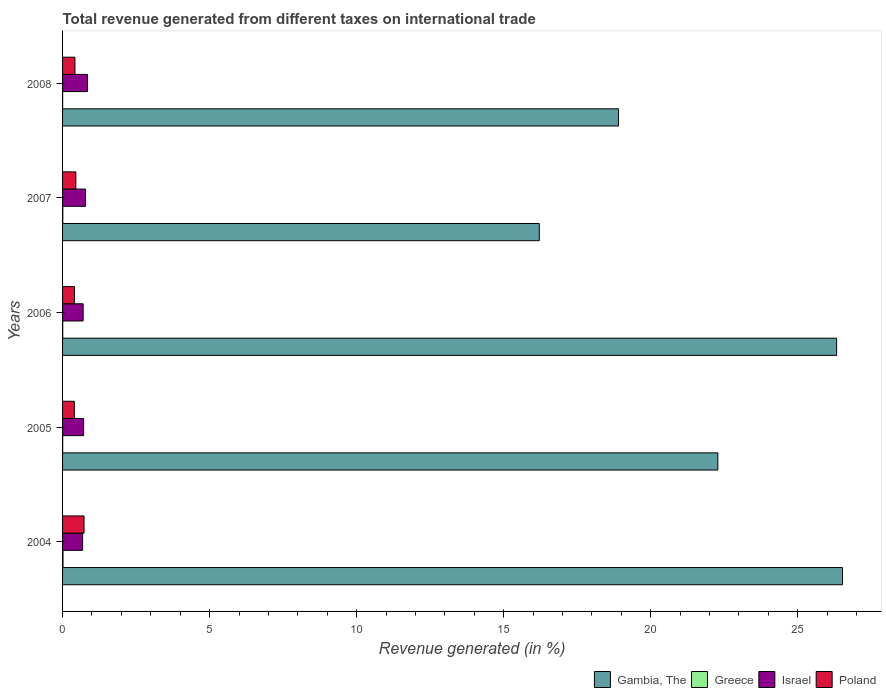How many groups of bars are there?
Your answer should be very brief. 5. How many bars are there on the 2nd tick from the top?
Ensure brevity in your answer.  4. How many bars are there on the 4th tick from the bottom?
Your response must be concise. 4. In how many cases, is the number of bars for a given year not equal to the number of legend labels?
Make the answer very short. 0. What is the total revenue generated in Poland in 2004?
Provide a short and direct response. 0.73. Across all years, what is the maximum total revenue generated in Greece?
Your response must be concise. 0.01. Across all years, what is the minimum total revenue generated in Greece?
Provide a short and direct response. 0. What is the total total revenue generated in Poland in the graph?
Your answer should be compact. 2.41. What is the difference between the total revenue generated in Gambia, The in 2004 and that in 2007?
Your answer should be compact. 10.31. What is the difference between the total revenue generated in Israel in 2004 and the total revenue generated in Poland in 2008?
Offer a very short reply. 0.26. What is the average total revenue generated in Greece per year?
Offer a terse response. 0.01. In the year 2008, what is the difference between the total revenue generated in Israel and total revenue generated in Greece?
Provide a short and direct response. 0.85. In how many years, is the total revenue generated in Israel greater than 15 %?
Keep it short and to the point. 0. What is the ratio of the total revenue generated in Poland in 2004 to that in 2005?
Ensure brevity in your answer.  1.82. Is the total revenue generated in Gambia, The in 2007 less than that in 2008?
Keep it short and to the point. Yes. What is the difference between the highest and the second highest total revenue generated in Poland?
Your response must be concise. 0.28. What is the difference between the highest and the lowest total revenue generated in Poland?
Give a very brief answer. 0.33. Is it the case that in every year, the sum of the total revenue generated in Israel and total revenue generated in Gambia, The is greater than the sum of total revenue generated in Poland and total revenue generated in Greece?
Ensure brevity in your answer.  Yes. What does the 4th bar from the top in 2007 represents?
Your answer should be compact. Gambia, The. Is it the case that in every year, the sum of the total revenue generated in Israel and total revenue generated in Greece is greater than the total revenue generated in Poland?
Your answer should be compact. No. How many bars are there?
Provide a succinct answer. 20. Are all the bars in the graph horizontal?
Keep it short and to the point. Yes. What is the difference between two consecutive major ticks on the X-axis?
Ensure brevity in your answer.  5. Does the graph contain any zero values?
Keep it short and to the point. No. Does the graph contain grids?
Provide a short and direct response. No. How many legend labels are there?
Ensure brevity in your answer.  4. What is the title of the graph?
Ensure brevity in your answer.  Total revenue generated from different taxes on international trade. Does "Venezuela" appear as one of the legend labels in the graph?
Your answer should be compact. No. What is the label or title of the X-axis?
Offer a terse response. Revenue generated (in %). What is the Revenue generated (in %) in Gambia, The in 2004?
Give a very brief answer. 26.52. What is the Revenue generated (in %) of Greece in 2004?
Provide a short and direct response. 0.01. What is the Revenue generated (in %) in Israel in 2004?
Give a very brief answer. 0.68. What is the Revenue generated (in %) of Poland in 2004?
Make the answer very short. 0.73. What is the Revenue generated (in %) in Gambia, The in 2005?
Keep it short and to the point. 22.28. What is the Revenue generated (in %) in Greece in 2005?
Your answer should be very brief. 0. What is the Revenue generated (in %) of Israel in 2005?
Your answer should be compact. 0.72. What is the Revenue generated (in %) in Poland in 2005?
Make the answer very short. 0.4. What is the Revenue generated (in %) of Gambia, The in 2006?
Your answer should be very brief. 26.32. What is the Revenue generated (in %) of Greece in 2006?
Offer a terse response. 0.01. What is the Revenue generated (in %) of Israel in 2006?
Your response must be concise. 0.7. What is the Revenue generated (in %) of Poland in 2006?
Offer a very short reply. 0.4. What is the Revenue generated (in %) of Gambia, The in 2007?
Make the answer very short. 16.21. What is the Revenue generated (in %) in Greece in 2007?
Keep it short and to the point. 0.01. What is the Revenue generated (in %) in Israel in 2007?
Ensure brevity in your answer.  0.78. What is the Revenue generated (in %) of Poland in 2007?
Your answer should be very brief. 0.45. What is the Revenue generated (in %) of Gambia, The in 2008?
Give a very brief answer. 18.9. What is the Revenue generated (in %) in Greece in 2008?
Ensure brevity in your answer.  0. What is the Revenue generated (in %) of Israel in 2008?
Your answer should be compact. 0.85. What is the Revenue generated (in %) in Poland in 2008?
Keep it short and to the point. 0.42. Across all years, what is the maximum Revenue generated (in %) in Gambia, The?
Provide a succinct answer. 26.52. Across all years, what is the maximum Revenue generated (in %) in Greece?
Provide a succinct answer. 0.01. Across all years, what is the maximum Revenue generated (in %) of Israel?
Ensure brevity in your answer.  0.85. Across all years, what is the maximum Revenue generated (in %) of Poland?
Give a very brief answer. 0.73. Across all years, what is the minimum Revenue generated (in %) in Gambia, The?
Offer a terse response. 16.21. Across all years, what is the minimum Revenue generated (in %) in Greece?
Keep it short and to the point. 0. Across all years, what is the minimum Revenue generated (in %) of Israel?
Offer a very short reply. 0.68. Across all years, what is the minimum Revenue generated (in %) of Poland?
Keep it short and to the point. 0.4. What is the total Revenue generated (in %) of Gambia, The in the graph?
Provide a succinct answer. 110.24. What is the total Revenue generated (in %) of Greece in the graph?
Your response must be concise. 0.03. What is the total Revenue generated (in %) in Israel in the graph?
Give a very brief answer. 3.73. What is the total Revenue generated (in %) of Poland in the graph?
Provide a short and direct response. 2.41. What is the difference between the Revenue generated (in %) of Gambia, The in 2004 and that in 2005?
Offer a terse response. 4.24. What is the difference between the Revenue generated (in %) in Greece in 2004 and that in 2005?
Offer a very short reply. 0.01. What is the difference between the Revenue generated (in %) in Israel in 2004 and that in 2005?
Offer a very short reply. -0.03. What is the difference between the Revenue generated (in %) in Poland in 2004 and that in 2005?
Give a very brief answer. 0.33. What is the difference between the Revenue generated (in %) of Gambia, The in 2004 and that in 2006?
Ensure brevity in your answer.  0.2. What is the difference between the Revenue generated (in %) in Greece in 2004 and that in 2006?
Provide a short and direct response. 0.01. What is the difference between the Revenue generated (in %) of Israel in 2004 and that in 2006?
Make the answer very short. -0.02. What is the difference between the Revenue generated (in %) of Poland in 2004 and that in 2006?
Provide a succinct answer. 0.33. What is the difference between the Revenue generated (in %) in Gambia, The in 2004 and that in 2007?
Offer a terse response. 10.31. What is the difference between the Revenue generated (in %) in Greece in 2004 and that in 2007?
Your answer should be very brief. 0.01. What is the difference between the Revenue generated (in %) of Israel in 2004 and that in 2007?
Provide a succinct answer. -0.1. What is the difference between the Revenue generated (in %) in Poland in 2004 and that in 2007?
Make the answer very short. 0.28. What is the difference between the Revenue generated (in %) of Gambia, The in 2004 and that in 2008?
Give a very brief answer. 7.62. What is the difference between the Revenue generated (in %) in Greece in 2004 and that in 2008?
Your answer should be compact. 0.01. What is the difference between the Revenue generated (in %) in Israel in 2004 and that in 2008?
Provide a short and direct response. -0.17. What is the difference between the Revenue generated (in %) in Poland in 2004 and that in 2008?
Your answer should be compact. 0.31. What is the difference between the Revenue generated (in %) in Gambia, The in 2005 and that in 2006?
Keep it short and to the point. -4.04. What is the difference between the Revenue generated (in %) in Greece in 2005 and that in 2006?
Make the answer very short. -0. What is the difference between the Revenue generated (in %) of Israel in 2005 and that in 2006?
Give a very brief answer. 0.02. What is the difference between the Revenue generated (in %) of Poland in 2005 and that in 2006?
Offer a very short reply. -0. What is the difference between the Revenue generated (in %) in Gambia, The in 2005 and that in 2007?
Your response must be concise. 6.07. What is the difference between the Revenue generated (in %) in Greece in 2005 and that in 2007?
Ensure brevity in your answer.  -0. What is the difference between the Revenue generated (in %) of Israel in 2005 and that in 2007?
Make the answer very short. -0.06. What is the difference between the Revenue generated (in %) of Poland in 2005 and that in 2007?
Provide a succinct answer. -0.05. What is the difference between the Revenue generated (in %) in Gambia, The in 2005 and that in 2008?
Offer a terse response. 3.38. What is the difference between the Revenue generated (in %) of Greece in 2005 and that in 2008?
Ensure brevity in your answer.  0. What is the difference between the Revenue generated (in %) of Israel in 2005 and that in 2008?
Your answer should be compact. -0.13. What is the difference between the Revenue generated (in %) in Poland in 2005 and that in 2008?
Give a very brief answer. -0.02. What is the difference between the Revenue generated (in %) in Gambia, The in 2006 and that in 2007?
Make the answer very short. 10.11. What is the difference between the Revenue generated (in %) in Greece in 2006 and that in 2007?
Give a very brief answer. -0. What is the difference between the Revenue generated (in %) of Israel in 2006 and that in 2007?
Provide a succinct answer. -0.08. What is the difference between the Revenue generated (in %) of Poland in 2006 and that in 2007?
Provide a short and direct response. -0.05. What is the difference between the Revenue generated (in %) in Gambia, The in 2006 and that in 2008?
Your answer should be very brief. 7.42. What is the difference between the Revenue generated (in %) in Greece in 2006 and that in 2008?
Provide a short and direct response. 0. What is the difference between the Revenue generated (in %) of Israel in 2006 and that in 2008?
Your answer should be very brief. -0.15. What is the difference between the Revenue generated (in %) of Poland in 2006 and that in 2008?
Your answer should be compact. -0.02. What is the difference between the Revenue generated (in %) in Gambia, The in 2007 and that in 2008?
Your answer should be compact. -2.69. What is the difference between the Revenue generated (in %) of Greece in 2007 and that in 2008?
Keep it short and to the point. 0.01. What is the difference between the Revenue generated (in %) in Israel in 2007 and that in 2008?
Your answer should be very brief. -0.07. What is the difference between the Revenue generated (in %) of Poland in 2007 and that in 2008?
Give a very brief answer. 0.03. What is the difference between the Revenue generated (in %) of Gambia, The in 2004 and the Revenue generated (in %) of Greece in 2005?
Provide a short and direct response. 26.52. What is the difference between the Revenue generated (in %) of Gambia, The in 2004 and the Revenue generated (in %) of Israel in 2005?
Give a very brief answer. 25.81. What is the difference between the Revenue generated (in %) of Gambia, The in 2004 and the Revenue generated (in %) of Poland in 2005?
Your response must be concise. 26.12. What is the difference between the Revenue generated (in %) in Greece in 2004 and the Revenue generated (in %) in Israel in 2005?
Provide a succinct answer. -0.7. What is the difference between the Revenue generated (in %) in Greece in 2004 and the Revenue generated (in %) in Poland in 2005?
Provide a short and direct response. -0.39. What is the difference between the Revenue generated (in %) of Israel in 2004 and the Revenue generated (in %) of Poland in 2005?
Offer a terse response. 0.28. What is the difference between the Revenue generated (in %) of Gambia, The in 2004 and the Revenue generated (in %) of Greece in 2006?
Your answer should be compact. 26.52. What is the difference between the Revenue generated (in %) of Gambia, The in 2004 and the Revenue generated (in %) of Israel in 2006?
Provide a succinct answer. 25.82. What is the difference between the Revenue generated (in %) in Gambia, The in 2004 and the Revenue generated (in %) in Poland in 2006?
Keep it short and to the point. 26.12. What is the difference between the Revenue generated (in %) in Greece in 2004 and the Revenue generated (in %) in Israel in 2006?
Make the answer very short. -0.68. What is the difference between the Revenue generated (in %) of Greece in 2004 and the Revenue generated (in %) of Poland in 2006?
Your response must be concise. -0.39. What is the difference between the Revenue generated (in %) of Israel in 2004 and the Revenue generated (in %) of Poland in 2006?
Provide a succinct answer. 0.28. What is the difference between the Revenue generated (in %) in Gambia, The in 2004 and the Revenue generated (in %) in Greece in 2007?
Your response must be concise. 26.51. What is the difference between the Revenue generated (in %) of Gambia, The in 2004 and the Revenue generated (in %) of Israel in 2007?
Your answer should be compact. 25.74. What is the difference between the Revenue generated (in %) in Gambia, The in 2004 and the Revenue generated (in %) in Poland in 2007?
Make the answer very short. 26.07. What is the difference between the Revenue generated (in %) in Greece in 2004 and the Revenue generated (in %) in Israel in 2007?
Ensure brevity in your answer.  -0.77. What is the difference between the Revenue generated (in %) in Greece in 2004 and the Revenue generated (in %) in Poland in 2007?
Ensure brevity in your answer.  -0.44. What is the difference between the Revenue generated (in %) in Israel in 2004 and the Revenue generated (in %) in Poland in 2007?
Provide a succinct answer. 0.23. What is the difference between the Revenue generated (in %) in Gambia, The in 2004 and the Revenue generated (in %) in Greece in 2008?
Give a very brief answer. 26.52. What is the difference between the Revenue generated (in %) of Gambia, The in 2004 and the Revenue generated (in %) of Israel in 2008?
Provide a succinct answer. 25.67. What is the difference between the Revenue generated (in %) in Gambia, The in 2004 and the Revenue generated (in %) in Poland in 2008?
Provide a succinct answer. 26.1. What is the difference between the Revenue generated (in %) of Greece in 2004 and the Revenue generated (in %) of Israel in 2008?
Give a very brief answer. -0.83. What is the difference between the Revenue generated (in %) in Greece in 2004 and the Revenue generated (in %) in Poland in 2008?
Your answer should be very brief. -0.41. What is the difference between the Revenue generated (in %) of Israel in 2004 and the Revenue generated (in %) of Poland in 2008?
Your response must be concise. 0.26. What is the difference between the Revenue generated (in %) of Gambia, The in 2005 and the Revenue generated (in %) of Greece in 2006?
Offer a very short reply. 22.28. What is the difference between the Revenue generated (in %) of Gambia, The in 2005 and the Revenue generated (in %) of Israel in 2006?
Provide a short and direct response. 21.58. What is the difference between the Revenue generated (in %) of Gambia, The in 2005 and the Revenue generated (in %) of Poland in 2006?
Your response must be concise. 21.88. What is the difference between the Revenue generated (in %) of Greece in 2005 and the Revenue generated (in %) of Israel in 2006?
Give a very brief answer. -0.7. What is the difference between the Revenue generated (in %) in Greece in 2005 and the Revenue generated (in %) in Poland in 2006?
Your answer should be very brief. -0.4. What is the difference between the Revenue generated (in %) of Israel in 2005 and the Revenue generated (in %) of Poland in 2006?
Give a very brief answer. 0.31. What is the difference between the Revenue generated (in %) of Gambia, The in 2005 and the Revenue generated (in %) of Greece in 2007?
Your response must be concise. 22.27. What is the difference between the Revenue generated (in %) in Gambia, The in 2005 and the Revenue generated (in %) in Israel in 2007?
Provide a succinct answer. 21.5. What is the difference between the Revenue generated (in %) in Gambia, The in 2005 and the Revenue generated (in %) in Poland in 2007?
Make the answer very short. 21.83. What is the difference between the Revenue generated (in %) in Greece in 2005 and the Revenue generated (in %) in Israel in 2007?
Give a very brief answer. -0.78. What is the difference between the Revenue generated (in %) of Greece in 2005 and the Revenue generated (in %) of Poland in 2007?
Provide a short and direct response. -0.45. What is the difference between the Revenue generated (in %) in Israel in 2005 and the Revenue generated (in %) in Poland in 2007?
Provide a short and direct response. 0.26. What is the difference between the Revenue generated (in %) of Gambia, The in 2005 and the Revenue generated (in %) of Greece in 2008?
Offer a very short reply. 22.28. What is the difference between the Revenue generated (in %) of Gambia, The in 2005 and the Revenue generated (in %) of Israel in 2008?
Keep it short and to the point. 21.43. What is the difference between the Revenue generated (in %) of Gambia, The in 2005 and the Revenue generated (in %) of Poland in 2008?
Make the answer very short. 21.86. What is the difference between the Revenue generated (in %) in Greece in 2005 and the Revenue generated (in %) in Israel in 2008?
Your answer should be very brief. -0.84. What is the difference between the Revenue generated (in %) in Greece in 2005 and the Revenue generated (in %) in Poland in 2008?
Offer a terse response. -0.42. What is the difference between the Revenue generated (in %) in Israel in 2005 and the Revenue generated (in %) in Poland in 2008?
Ensure brevity in your answer.  0.3. What is the difference between the Revenue generated (in %) in Gambia, The in 2006 and the Revenue generated (in %) in Greece in 2007?
Provide a succinct answer. 26.31. What is the difference between the Revenue generated (in %) in Gambia, The in 2006 and the Revenue generated (in %) in Israel in 2007?
Give a very brief answer. 25.54. What is the difference between the Revenue generated (in %) in Gambia, The in 2006 and the Revenue generated (in %) in Poland in 2007?
Make the answer very short. 25.87. What is the difference between the Revenue generated (in %) of Greece in 2006 and the Revenue generated (in %) of Israel in 2007?
Your answer should be very brief. -0.78. What is the difference between the Revenue generated (in %) of Greece in 2006 and the Revenue generated (in %) of Poland in 2007?
Your answer should be very brief. -0.45. What is the difference between the Revenue generated (in %) of Israel in 2006 and the Revenue generated (in %) of Poland in 2007?
Provide a succinct answer. 0.25. What is the difference between the Revenue generated (in %) in Gambia, The in 2006 and the Revenue generated (in %) in Greece in 2008?
Your response must be concise. 26.32. What is the difference between the Revenue generated (in %) in Gambia, The in 2006 and the Revenue generated (in %) in Israel in 2008?
Your answer should be very brief. 25.47. What is the difference between the Revenue generated (in %) of Gambia, The in 2006 and the Revenue generated (in %) of Poland in 2008?
Provide a succinct answer. 25.9. What is the difference between the Revenue generated (in %) in Greece in 2006 and the Revenue generated (in %) in Israel in 2008?
Ensure brevity in your answer.  -0.84. What is the difference between the Revenue generated (in %) of Greece in 2006 and the Revenue generated (in %) of Poland in 2008?
Your answer should be compact. -0.42. What is the difference between the Revenue generated (in %) in Israel in 2006 and the Revenue generated (in %) in Poland in 2008?
Your answer should be very brief. 0.28. What is the difference between the Revenue generated (in %) of Gambia, The in 2007 and the Revenue generated (in %) of Greece in 2008?
Offer a terse response. 16.21. What is the difference between the Revenue generated (in %) of Gambia, The in 2007 and the Revenue generated (in %) of Israel in 2008?
Provide a succinct answer. 15.36. What is the difference between the Revenue generated (in %) in Gambia, The in 2007 and the Revenue generated (in %) in Poland in 2008?
Provide a succinct answer. 15.79. What is the difference between the Revenue generated (in %) in Greece in 2007 and the Revenue generated (in %) in Israel in 2008?
Provide a short and direct response. -0.84. What is the difference between the Revenue generated (in %) in Greece in 2007 and the Revenue generated (in %) in Poland in 2008?
Your response must be concise. -0.41. What is the difference between the Revenue generated (in %) of Israel in 2007 and the Revenue generated (in %) of Poland in 2008?
Keep it short and to the point. 0.36. What is the average Revenue generated (in %) of Gambia, The per year?
Offer a terse response. 22.05. What is the average Revenue generated (in %) of Greece per year?
Provide a succinct answer. 0.01. What is the average Revenue generated (in %) of Israel per year?
Make the answer very short. 0.75. What is the average Revenue generated (in %) of Poland per year?
Offer a very short reply. 0.48. In the year 2004, what is the difference between the Revenue generated (in %) in Gambia, The and Revenue generated (in %) in Greece?
Your answer should be compact. 26.51. In the year 2004, what is the difference between the Revenue generated (in %) of Gambia, The and Revenue generated (in %) of Israel?
Provide a succinct answer. 25.84. In the year 2004, what is the difference between the Revenue generated (in %) in Gambia, The and Revenue generated (in %) in Poland?
Give a very brief answer. 25.79. In the year 2004, what is the difference between the Revenue generated (in %) of Greece and Revenue generated (in %) of Israel?
Provide a succinct answer. -0.67. In the year 2004, what is the difference between the Revenue generated (in %) of Greece and Revenue generated (in %) of Poland?
Offer a very short reply. -0.72. In the year 2004, what is the difference between the Revenue generated (in %) of Israel and Revenue generated (in %) of Poland?
Keep it short and to the point. -0.05. In the year 2005, what is the difference between the Revenue generated (in %) of Gambia, The and Revenue generated (in %) of Greece?
Ensure brevity in your answer.  22.28. In the year 2005, what is the difference between the Revenue generated (in %) in Gambia, The and Revenue generated (in %) in Israel?
Make the answer very short. 21.57. In the year 2005, what is the difference between the Revenue generated (in %) in Gambia, The and Revenue generated (in %) in Poland?
Your answer should be compact. 21.88. In the year 2005, what is the difference between the Revenue generated (in %) in Greece and Revenue generated (in %) in Israel?
Provide a succinct answer. -0.71. In the year 2005, what is the difference between the Revenue generated (in %) in Greece and Revenue generated (in %) in Poland?
Your answer should be compact. -0.4. In the year 2005, what is the difference between the Revenue generated (in %) of Israel and Revenue generated (in %) of Poland?
Keep it short and to the point. 0.32. In the year 2006, what is the difference between the Revenue generated (in %) in Gambia, The and Revenue generated (in %) in Greece?
Your answer should be compact. 26.32. In the year 2006, what is the difference between the Revenue generated (in %) of Gambia, The and Revenue generated (in %) of Israel?
Ensure brevity in your answer.  25.62. In the year 2006, what is the difference between the Revenue generated (in %) in Gambia, The and Revenue generated (in %) in Poland?
Your answer should be very brief. 25.92. In the year 2006, what is the difference between the Revenue generated (in %) in Greece and Revenue generated (in %) in Israel?
Keep it short and to the point. -0.69. In the year 2006, what is the difference between the Revenue generated (in %) of Greece and Revenue generated (in %) of Poland?
Provide a succinct answer. -0.4. In the year 2006, what is the difference between the Revenue generated (in %) in Israel and Revenue generated (in %) in Poland?
Offer a terse response. 0.3. In the year 2007, what is the difference between the Revenue generated (in %) of Gambia, The and Revenue generated (in %) of Greece?
Give a very brief answer. 16.2. In the year 2007, what is the difference between the Revenue generated (in %) of Gambia, The and Revenue generated (in %) of Israel?
Offer a terse response. 15.43. In the year 2007, what is the difference between the Revenue generated (in %) in Gambia, The and Revenue generated (in %) in Poland?
Your response must be concise. 15.76. In the year 2007, what is the difference between the Revenue generated (in %) of Greece and Revenue generated (in %) of Israel?
Make the answer very short. -0.77. In the year 2007, what is the difference between the Revenue generated (in %) in Greece and Revenue generated (in %) in Poland?
Keep it short and to the point. -0.44. In the year 2007, what is the difference between the Revenue generated (in %) of Israel and Revenue generated (in %) of Poland?
Provide a short and direct response. 0.33. In the year 2008, what is the difference between the Revenue generated (in %) in Gambia, The and Revenue generated (in %) in Greece?
Your response must be concise. 18.9. In the year 2008, what is the difference between the Revenue generated (in %) in Gambia, The and Revenue generated (in %) in Israel?
Make the answer very short. 18.06. In the year 2008, what is the difference between the Revenue generated (in %) in Gambia, The and Revenue generated (in %) in Poland?
Your response must be concise. 18.48. In the year 2008, what is the difference between the Revenue generated (in %) of Greece and Revenue generated (in %) of Israel?
Provide a succinct answer. -0.85. In the year 2008, what is the difference between the Revenue generated (in %) of Greece and Revenue generated (in %) of Poland?
Offer a terse response. -0.42. In the year 2008, what is the difference between the Revenue generated (in %) in Israel and Revenue generated (in %) in Poland?
Keep it short and to the point. 0.43. What is the ratio of the Revenue generated (in %) in Gambia, The in 2004 to that in 2005?
Make the answer very short. 1.19. What is the ratio of the Revenue generated (in %) of Greece in 2004 to that in 2005?
Your answer should be compact. 3.55. What is the ratio of the Revenue generated (in %) in Israel in 2004 to that in 2005?
Offer a very short reply. 0.95. What is the ratio of the Revenue generated (in %) of Poland in 2004 to that in 2005?
Keep it short and to the point. 1.82. What is the ratio of the Revenue generated (in %) in Gambia, The in 2004 to that in 2006?
Provide a succinct answer. 1.01. What is the ratio of the Revenue generated (in %) of Greece in 2004 to that in 2006?
Your response must be concise. 2.9. What is the ratio of the Revenue generated (in %) of Israel in 2004 to that in 2006?
Make the answer very short. 0.98. What is the ratio of the Revenue generated (in %) of Poland in 2004 to that in 2006?
Offer a terse response. 1.81. What is the ratio of the Revenue generated (in %) of Gambia, The in 2004 to that in 2007?
Offer a very short reply. 1.64. What is the ratio of the Revenue generated (in %) of Greece in 2004 to that in 2007?
Your response must be concise. 1.84. What is the ratio of the Revenue generated (in %) in Israel in 2004 to that in 2007?
Provide a short and direct response. 0.87. What is the ratio of the Revenue generated (in %) of Poland in 2004 to that in 2007?
Offer a terse response. 1.62. What is the ratio of the Revenue generated (in %) in Gambia, The in 2004 to that in 2008?
Keep it short and to the point. 1.4. What is the ratio of the Revenue generated (in %) of Greece in 2004 to that in 2008?
Your answer should be compact. 6.71. What is the ratio of the Revenue generated (in %) in Israel in 2004 to that in 2008?
Keep it short and to the point. 0.8. What is the ratio of the Revenue generated (in %) of Poland in 2004 to that in 2008?
Your response must be concise. 1.74. What is the ratio of the Revenue generated (in %) in Gambia, The in 2005 to that in 2006?
Your answer should be very brief. 0.85. What is the ratio of the Revenue generated (in %) of Greece in 2005 to that in 2006?
Keep it short and to the point. 0.82. What is the ratio of the Revenue generated (in %) in Israel in 2005 to that in 2006?
Give a very brief answer. 1.02. What is the ratio of the Revenue generated (in %) of Gambia, The in 2005 to that in 2007?
Offer a terse response. 1.37. What is the ratio of the Revenue generated (in %) in Greece in 2005 to that in 2007?
Offer a very short reply. 0.52. What is the ratio of the Revenue generated (in %) of Israel in 2005 to that in 2007?
Make the answer very short. 0.92. What is the ratio of the Revenue generated (in %) in Poland in 2005 to that in 2007?
Ensure brevity in your answer.  0.89. What is the ratio of the Revenue generated (in %) of Gambia, The in 2005 to that in 2008?
Provide a short and direct response. 1.18. What is the ratio of the Revenue generated (in %) in Greece in 2005 to that in 2008?
Keep it short and to the point. 1.89. What is the ratio of the Revenue generated (in %) in Israel in 2005 to that in 2008?
Ensure brevity in your answer.  0.84. What is the ratio of the Revenue generated (in %) in Poland in 2005 to that in 2008?
Make the answer very short. 0.95. What is the ratio of the Revenue generated (in %) of Gambia, The in 2006 to that in 2007?
Provide a short and direct response. 1.62. What is the ratio of the Revenue generated (in %) in Greece in 2006 to that in 2007?
Your answer should be very brief. 0.63. What is the ratio of the Revenue generated (in %) in Israel in 2006 to that in 2007?
Your answer should be very brief. 0.9. What is the ratio of the Revenue generated (in %) in Poland in 2006 to that in 2007?
Your response must be concise. 0.89. What is the ratio of the Revenue generated (in %) of Gambia, The in 2006 to that in 2008?
Offer a terse response. 1.39. What is the ratio of the Revenue generated (in %) of Greece in 2006 to that in 2008?
Offer a terse response. 2.32. What is the ratio of the Revenue generated (in %) in Israel in 2006 to that in 2008?
Provide a succinct answer. 0.82. What is the ratio of the Revenue generated (in %) of Poland in 2006 to that in 2008?
Your response must be concise. 0.96. What is the ratio of the Revenue generated (in %) of Gambia, The in 2007 to that in 2008?
Ensure brevity in your answer.  0.86. What is the ratio of the Revenue generated (in %) in Greece in 2007 to that in 2008?
Keep it short and to the point. 3.65. What is the ratio of the Revenue generated (in %) in Israel in 2007 to that in 2008?
Provide a succinct answer. 0.92. What is the ratio of the Revenue generated (in %) of Poland in 2007 to that in 2008?
Provide a short and direct response. 1.07. What is the difference between the highest and the second highest Revenue generated (in %) of Gambia, The?
Offer a terse response. 0.2. What is the difference between the highest and the second highest Revenue generated (in %) of Greece?
Provide a succinct answer. 0.01. What is the difference between the highest and the second highest Revenue generated (in %) in Israel?
Your response must be concise. 0.07. What is the difference between the highest and the second highest Revenue generated (in %) in Poland?
Make the answer very short. 0.28. What is the difference between the highest and the lowest Revenue generated (in %) in Gambia, The?
Your response must be concise. 10.31. What is the difference between the highest and the lowest Revenue generated (in %) of Greece?
Provide a short and direct response. 0.01. What is the difference between the highest and the lowest Revenue generated (in %) in Israel?
Offer a very short reply. 0.17. What is the difference between the highest and the lowest Revenue generated (in %) of Poland?
Ensure brevity in your answer.  0.33. 